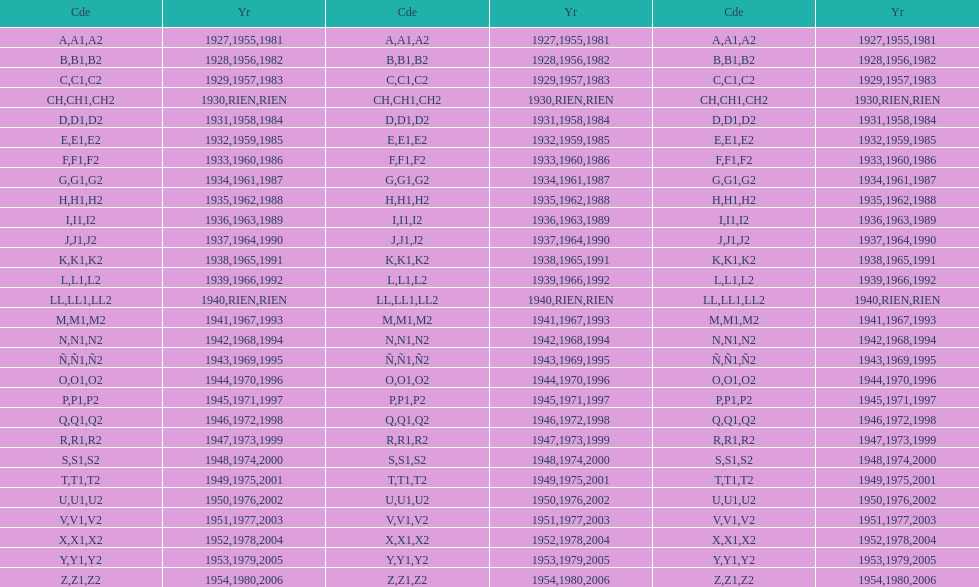Number of codes containing a 2? 28. 